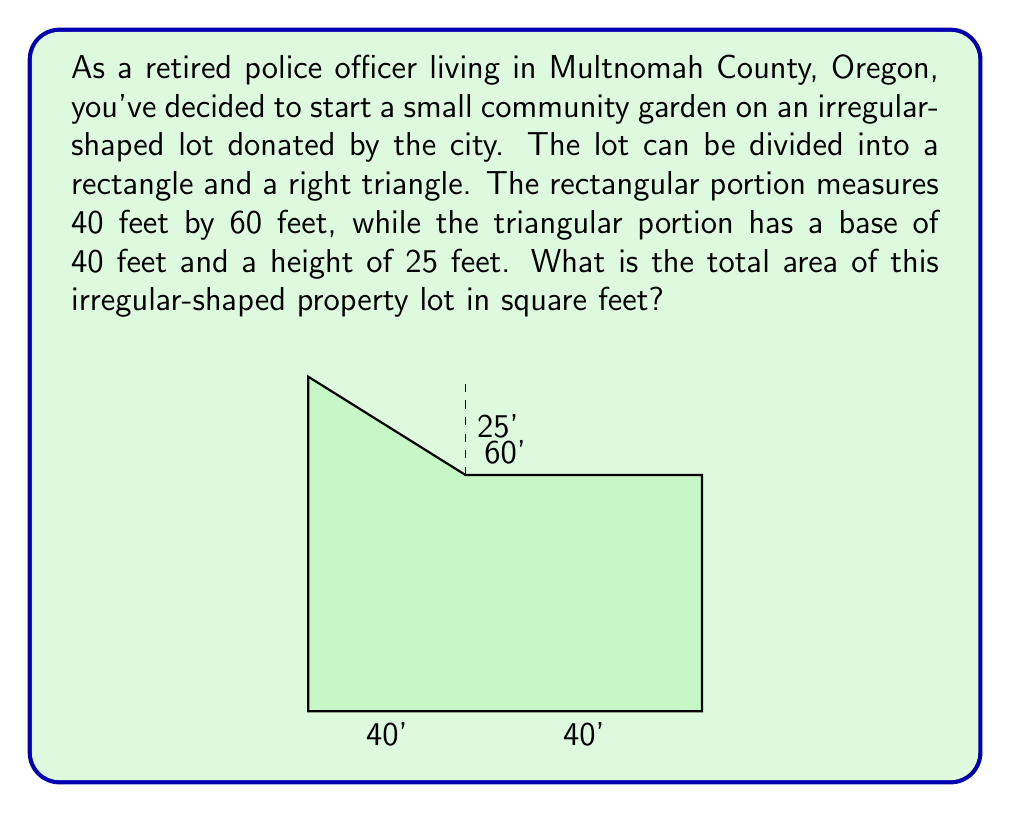Show me your answer to this math problem. To solve this problem, we need to calculate the areas of the rectangular and triangular portions separately, then add them together.

1. Area of the rectangle:
   $$ A_{rectangle} = length \times width $$
   $$ A_{rectangle} = 60 \text{ ft} \times 40 \text{ ft} = 2400 \text{ sq ft} $$

2. Area of the right triangle:
   $$ A_{triangle} = \frac{1}{2} \times base \times height $$
   $$ A_{triangle} = \frac{1}{2} \times 40 \text{ ft} \times 25 \text{ ft} = 500 \text{ sq ft} $$

3. Total area of the irregular-shaped lot:
   $$ A_{total} = A_{rectangle} + A_{triangle} $$
   $$ A_{total} = 2400 \text{ sq ft} + 500 \text{ sq ft} = 2900 \text{ sq ft} $$

Therefore, the total area of the irregular-shaped property lot is 2900 square feet.
Answer: 2900 square feet 